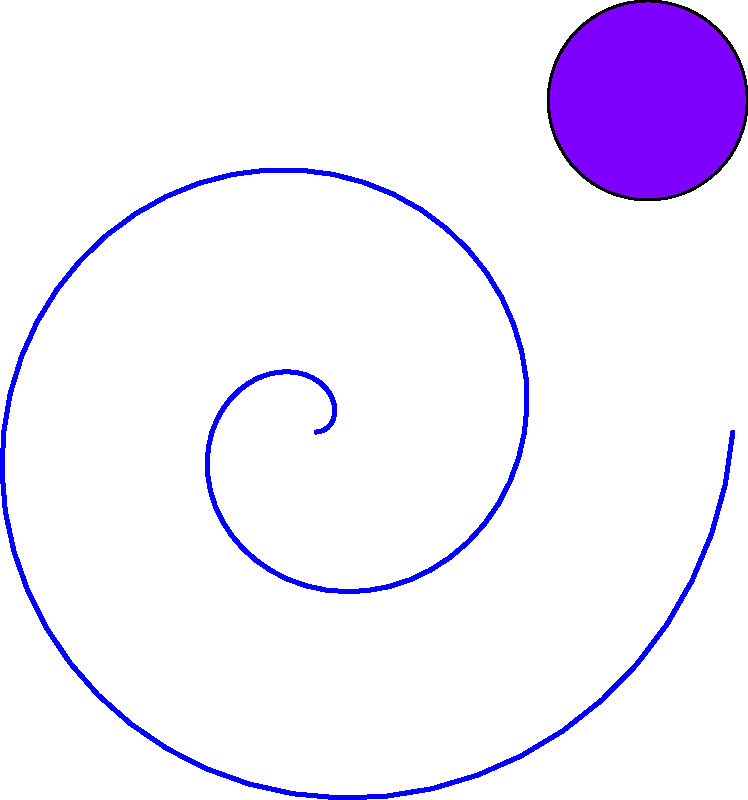In your surreal artwork, you've created a spiral-shaped path connecting three abstract shapes in 2D space. The spiral starts at the origin and is described by the parametric equations $x = at\cos(t)$ and $y = at\sin(t)$, where $a$ is a constant and $t$ is the parameter. If the spiral passes through the center of the triangle (point B) at $(-1, -1)$ when $t = \pi$, determine the equation of the spiral in polar form $(r, \theta)$. To solve this problem, let's follow these steps:

1) We know that the spiral passes through $(-1, -1)$ when $t = \pi$. Let's use this information:

   $x = at\cos(t) = -1$
   $y = at\sin(t) = -1$

2) When $t = \pi$:
   
   $-1 = a\pi\cos(\pi) = -a\pi$
   $-1 = a\pi\sin(\pi) = 0$

3) From the x-equation:
   
   $a\pi = 1$
   $a = \frac{1}{\pi}$

4) Now we have the parametric equations:

   $x = \frac{t}{\pi}\cos(t)$
   $y = \frac{t}{\pi}\sin(t)$

5) To convert to polar form, recall that:

   $r = \sqrt{x^2 + y^2}$
   $\theta = t$

6) Substituting our equations:

   $r = \sqrt{(\frac{t}{\pi}\cos(t))^2 + (\frac{t}{\pi}\sin(t))^2}$

7) Simplify:

   $r = \frac{t}{\pi}\sqrt{\cos^2(t) + \sin^2(t)} = \frac{t}{\pi}$

8) Therefore, our polar equation is:

   $r = \frac{\theta}{\pi}$
Answer: $r = \frac{\theta}{\pi}$ 